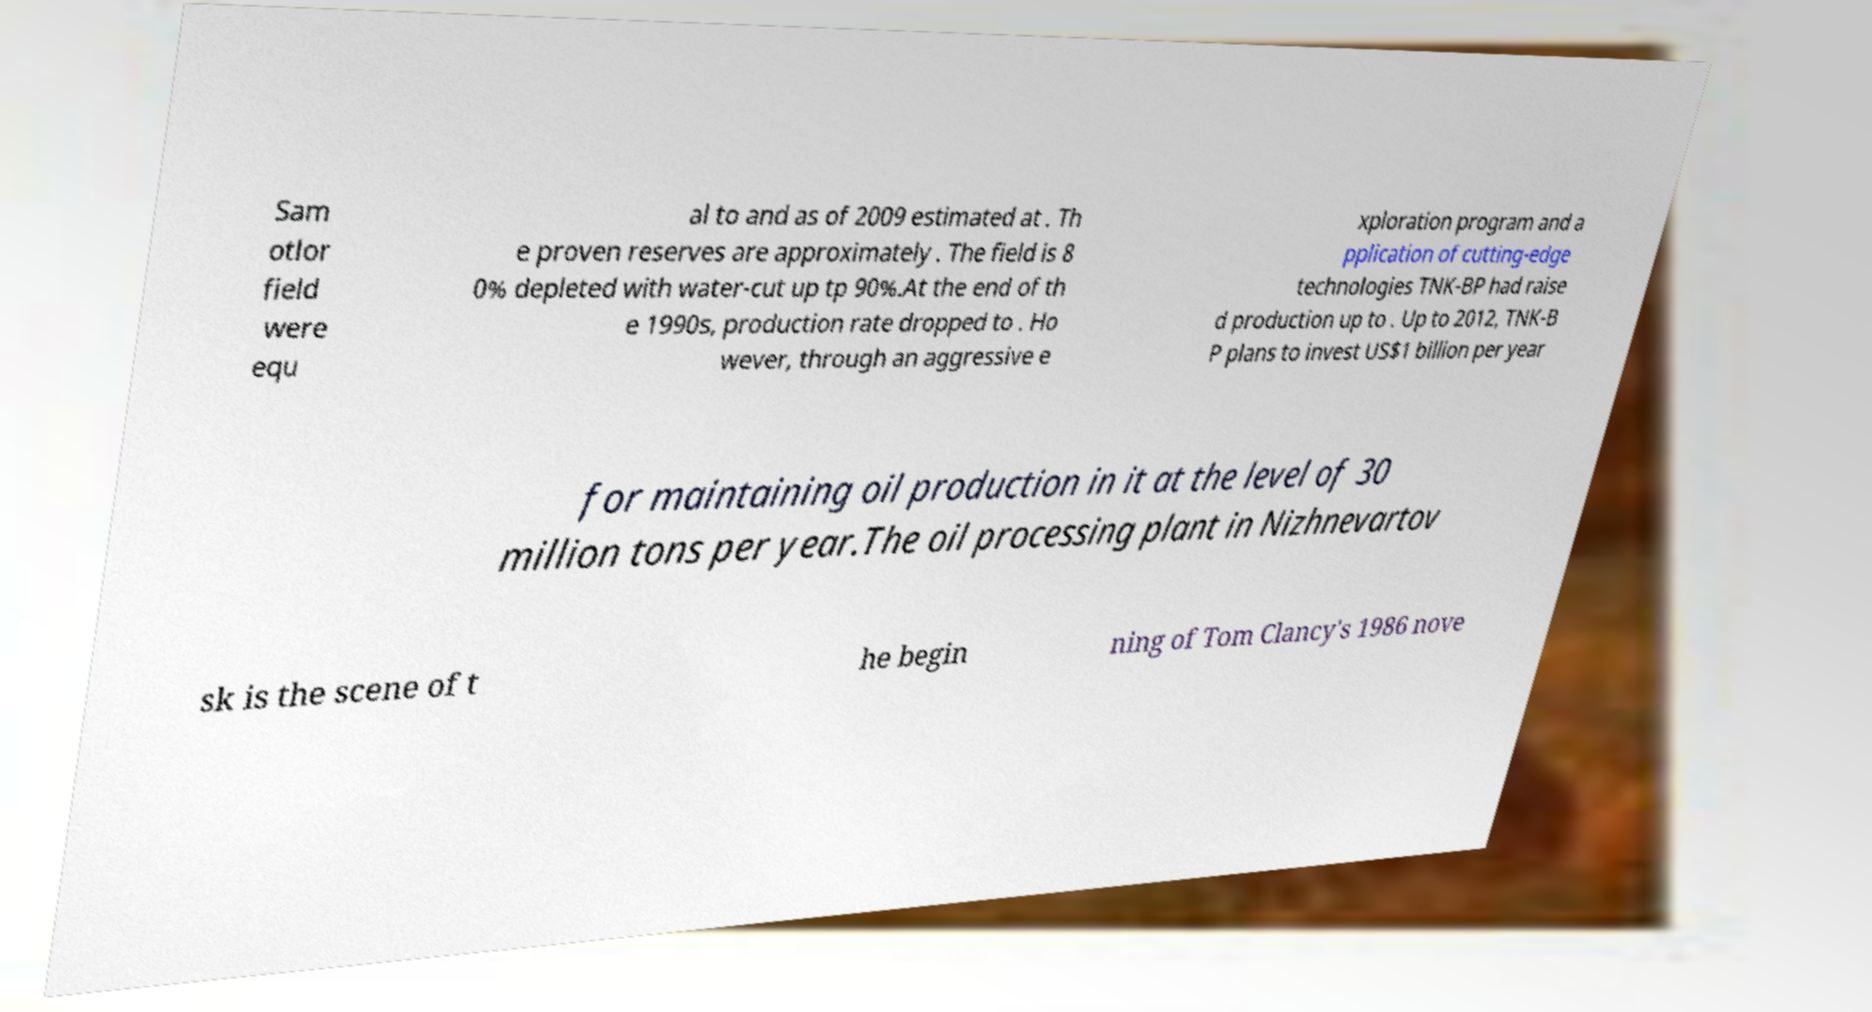Please read and relay the text visible in this image. What does it say? Sam otlor field were equ al to and as of 2009 estimated at . Th e proven reserves are approximately . The field is 8 0% depleted with water-cut up tp 90%.At the end of th e 1990s, production rate dropped to . Ho wever, through an aggressive e xploration program and a pplication of cutting-edge technologies TNK-BP had raise d production up to . Up to 2012, TNK-B P plans to invest US$1 billion per year for maintaining oil production in it at the level of 30 million tons per year.The oil processing plant in Nizhnevartov sk is the scene of t he begin ning of Tom Clancy's 1986 nove 